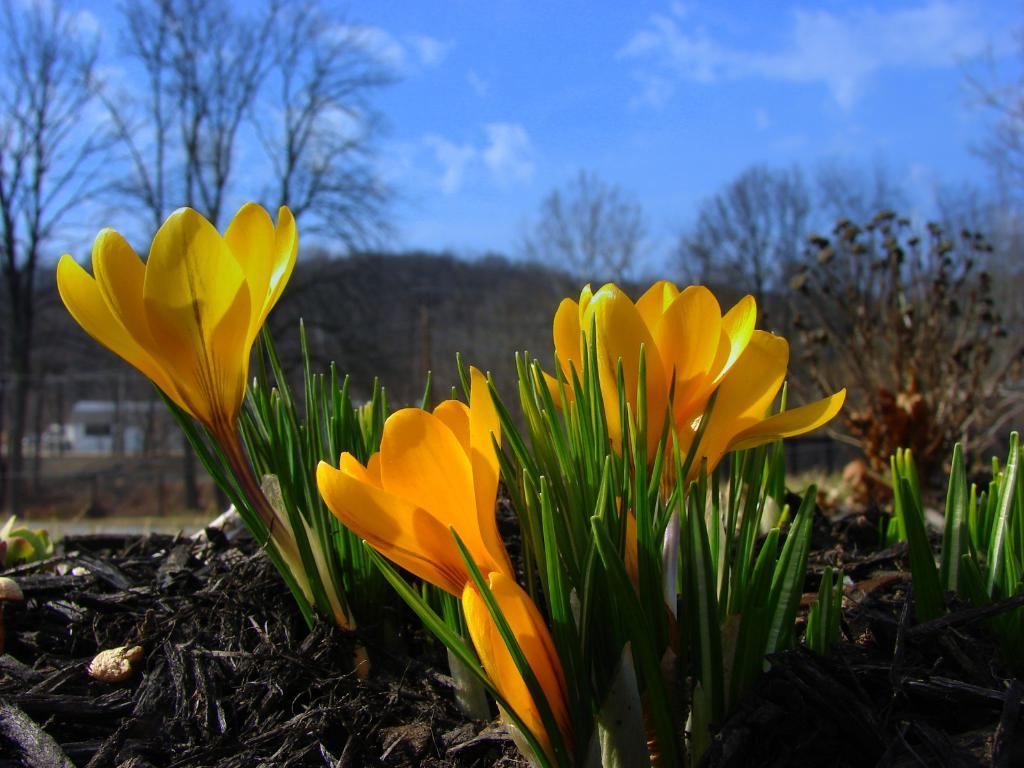What type of flowers can be seen in the image? There are yellow color flowers in the image. What else is present in the image besides the flowers? There are leaves and soil visible in the image. What is visible at the top of the image? The sky is visible at the top of the image. Can you see a giraffe nesting in the leaves in the image? There is no giraffe or nest present in the image; it features yellow flowers, leaves, and soil. What is the tendency of the flowers to grow in the image? The provided facts do not mention any information about the growth tendency of the flowers in the image. 